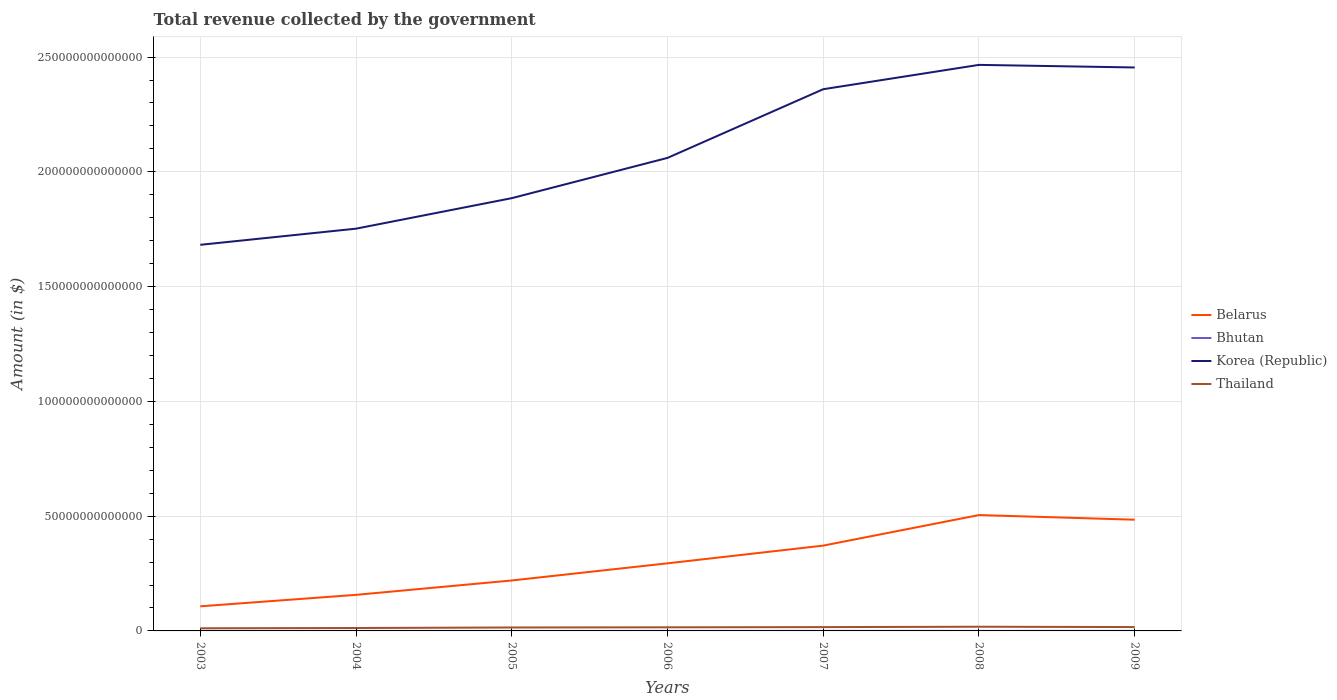Does the line corresponding to Belarus intersect with the line corresponding to Thailand?
Offer a very short reply. No. Is the number of lines equal to the number of legend labels?
Offer a terse response. Yes. Across all years, what is the maximum total revenue collected by the government in Belarus?
Ensure brevity in your answer.  1.07e+13. In which year was the total revenue collected by the government in Belarus maximum?
Make the answer very short. 2003. What is the total total revenue collected by the government in Korea (Republic) in the graph?
Keep it short and to the point. -4.05e+13. What is the difference between the highest and the second highest total revenue collected by the government in Korea (Republic)?
Ensure brevity in your answer.  7.84e+13. What is the difference between the highest and the lowest total revenue collected by the government in Belarus?
Offer a very short reply. 3. How many lines are there?
Provide a succinct answer. 4. What is the difference between two consecutive major ticks on the Y-axis?
Keep it short and to the point. 5.00e+13. Are the values on the major ticks of Y-axis written in scientific E-notation?
Your answer should be compact. No. Does the graph contain grids?
Provide a short and direct response. Yes. How many legend labels are there?
Keep it short and to the point. 4. What is the title of the graph?
Your answer should be compact. Total revenue collected by the government. Does "Norway" appear as one of the legend labels in the graph?
Make the answer very short. No. What is the label or title of the Y-axis?
Your response must be concise. Amount (in $). What is the Amount (in $) of Belarus in 2003?
Your answer should be very brief. 1.07e+13. What is the Amount (in $) in Bhutan in 2003?
Give a very brief answer. 4.75e+09. What is the Amount (in $) of Korea (Republic) in 2003?
Give a very brief answer. 1.68e+14. What is the Amount (in $) in Thailand in 2003?
Ensure brevity in your answer.  1.16e+12. What is the Amount (in $) in Belarus in 2004?
Ensure brevity in your answer.  1.57e+13. What is the Amount (in $) of Bhutan in 2004?
Ensure brevity in your answer.  5.00e+09. What is the Amount (in $) in Korea (Republic) in 2004?
Your response must be concise. 1.75e+14. What is the Amount (in $) of Thailand in 2004?
Make the answer very short. 1.27e+12. What is the Amount (in $) in Belarus in 2005?
Offer a very short reply. 2.20e+13. What is the Amount (in $) of Bhutan in 2005?
Make the answer very short. 6.07e+09. What is the Amount (in $) in Korea (Republic) in 2005?
Ensure brevity in your answer.  1.89e+14. What is the Amount (in $) in Thailand in 2005?
Keep it short and to the point. 1.50e+12. What is the Amount (in $) in Belarus in 2006?
Give a very brief answer. 2.94e+13. What is the Amount (in $) in Bhutan in 2006?
Offer a terse response. 6.90e+09. What is the Amount (in $) of Korea (Republic) in 2006?
Keep it short and to the point. 2.06e+14. What is the Amount (in $) of Thailand in 2006?
Provide a short and direct response. 1.57e+12. What is the Amount (in $) in Belarus in 2007?
Your answer should be very brief. 3.72e+13. What is the Amount (in $) of Bhutan in 2007?
Your response must be concise. 1.01e+1. What is the Amount (in $) in Korea (Republic) in 2007?
Offer a terse response. 2.36e+14. What is the Amount (in $) in Thailand in 2007?
Make the answer very short. 1.66e+12. What is the Amount (in $) of Belarus in 2008?
Give a very brief answer. 5.05e+13. What is the Amount (in $) of Bhutan in 2008?
Your answer should be very brief. 1.23e+1. What is the Amount (in $) of Korea (Republic) in 2008?
Offer a very short reply. 2.47e+14. What is the Amount (in $) in Thailand in 2008?
Your response must be concise. 1.83e+12. What is the Amount (in $) in Belarus in 2009?
Ensure brevity in your answer.  4.85e+13. What is the Amount (in $) of Bhutan in 2009?
Offer a very short reply. 1.40e+1. What is the Amount (in $) in Korea (Republic) in 2009?
Ensure brevity in your answer.  2.45e+14. What is the Amount (in $) in Thailand in 2009?
Make the answer very short. 1.68e+12. Across all years, what is the maximum Amount (in $) of Belarus?
Your answer should be very brief. 5.05e+13. Across all years, what is the maximum Amount (in $) of Bhutan?
Offer a terse response. 1.40e+1. Across all years, what is the maximum Amount (in $) of Korea (Republic)?
Offer a very short reply. 2.47e+14. Across all years, what is the maximum Amount (in $) in Thailand?
Make the answer very short. 1.83e+12. Across all years, what is the minimum Amount (in $) of Belarus?
Your answer should be very brief. 1.07e+13. Across all years, what is the minimum Amount (in $) of Bhutan?
Give a very brief answer. 4.75e+09. Across all years, what is the minimum Amount (in $) of Korea (Republic)?
Your response must be concise. 1.68e+14. Across all years, what is the minimum Amount (in $) in Thailand?
Ensure brevity in your answer.  1.16e+12. What is the total Amount (in $) of Belarus in the graph?
Provide a short and direct response. 2.14e+14. What is the total Amount (in $) in Bhutan in the graph?
Provide a short and direct response. 5.92e+1. What is the total Amount (in $) in Korea (Republic) in the graph?
Your answer should be compact. 1.47e+15. What is the total Amount (in $) of Thailand in the graph?
Your answer should be very brief. 1.07e+13. What is the difference between the Amount (in $) of Belarus in 2003 and that in 2004?
Offer a very short reply. -4.99e+12. What is the difference between the Amount (in $) of Bhutan in 2003 and that in 2004?
Your answer should be very brief. -2.58e+08. What is the difference between the Amount (in $) of Korea (Republic) in 2003 and that in 2004?
Your answer should be compact. -7.03e+12. What is the difference between the Amount (in $) in Thailand in 2003 and that in 2004?
Offer a terse response. -1.16e+11. What is the difference between the Amount (in $) of Belarus in 2003 and that in 2005?
Keep it short and to the point. -1.13e+13. What is the difference between the Amount (in $) in Bhutan in 2003 and that in 2005?
Make the answer very short. -1.32e+09. What is the difference between the Amount (in $) in Korea (Republic) in 2003 and that in 2005?
Ensure brevity in your answer.  -2.03e+13. What is the difference between the Amount (in $) in Thailand in 2003 and that in 2005?
Make the answer very short. -3.40e+11. What is the difference between the Amount (in $) of Belarus in 2003 and that in 2006?
Offer a terse response. -1.87e+13. What is the difference between the Amount (in $) of Bhutan in 2003 and that in 2006?
Make the answer very short. -2.16e+09. What is the difference between the Amount (in $) in Korea (Republic) in 2003 and that in 2006?
Your answer should be compact. -3.79e+13. What is the difference between the Amount (in $) of Thailand in 2003 and that in 2006?
Provide a succinct answer. -4.18e+11. What is the difference between the Amount (in $) in Belarus in 2003 and that in 2007?
Ensure brevity in your answer.  -2.64e+13. What is the difference between the Amount (in $) of Bhutan in 2003 and that in 2007?
Make the answer very short. -5.34e+09. What is the difference between the Amount (in $) in Korea (Republic) in 2003 and that in 2007?
Offer a very short reply. -6.78e+13. What is the difference between the Amount (in $) in Thailand in 2003 and that in 2007?
Give a very brief answer. -5.01e+11. What is the difference between the Amount (in $) of Belarus in 2003 and that in 2008?
Keep it short and to the point. -3.98e+13. What is the difference between the Amount (in $) in Bhutan in 2003 and that in 2008?
Your answer should be compact. -7.60e+09. What is the difference between the Amount (in $) in Korea (Republic) in 2003 and that in 2008?
Your answer should be compact. -7.84e+13. What is the difference between the Amount (in $) of Thailand in 2003 and that in 2008?
Your answer should be very brief. -6.70e+11. What is the difference between the Amount (in $) in Belarus in 2003 and that in 2009?
Offer a very short reply. -3.77e+13. What is the difference between the Amount (in $) in Bhutan in 2003 and that in 2009?
Offer a very short reply. -9.30e+09. What is the difference between the Amount (in $) in Korea (Republic) in 2003 and that in 2009?
Keep it short and to the point. -7.73e+13. What is the difference between the Amount (in $) in Thailand in 2003 and that in 2009?
Ensure brevity in your answer.  -5.28e+11. What is the difference between the Amount (in $) of Belarus in 2004 and that in 2005?
Offer a terse response. -6.26e+12. What is the difference between the Amount (in $) of Bhutan in 2004 and that in 2005?
Provide a succinct answer. -1.06e+09. What is the difference between the Amount (in $) in Korea (Republic) in 2004 and that in 2005?
Your answer should be compact. -1.33e+13. What is the difference between the Amount (in $) in Thailand in 2004 and that in 2005?
Offer a very short reply. -2.24e+11. What is the difference between the Amount (in $) of Belarus in 2004 and that in 2006?
Your answer should be compact. -1.37e+13. What is the difference between the Amount (in $) of Bhutan in 2004 and that in 2006?
Make the answer very short. -1.90e+09. What is the difference between the Amount (in $) of Korea (Republic) in 2004 and that in 2006?
Give a very brief answer. -3.08e+13. What is the difference between the Amount (in $) in Thailand in 2004 and that in 2006?
Your answer should be very brief. -3.02e+11. What is the difference between the Amount (in $) of Belarus in 2004 and that in 2007?
Give a very brief answer. -2.15e+13. What is the difference between the Amount (in $) in Bhutan in 2004 and that in 2007?
Provide a succinct answer. -5.08e+09. What is the difference between the Amount (in $) of Korea (Republic) in 2004 and that in 2007?
Offer a terse response. -6.08e+13. What is the difference between the Amount (in $) of Thailand in 2004 and that in 2007?
Offer a very short reply. -3.85e+11. What is the difference between the Amount (in $) of Belarus in 2004 and that in 2008?
Your answer should be compact. -3.48e+13. What is the difference between the Amount (in $) of Bhutan in 2004 and that in 2008?
Provide a short and direct response. -7.34e+09. What is the difference between the Amount (in $) in Korea (Republic) in 2004 and that in 2008?
Keep it short and to the point. -7.14e+13. What is the difference between the Amount (in $) of Thailand in 2004 and that in 2008?
Your answer should be compact. -5.54e+11. What is the difference between the Amount (in $) in Belarus in 2004 and that in 2009?
Offer a terse response. -3.27e+13. What is the difference between the Amount (in $) of Bhutan in 2004 and that in 2009?
Ensure brevity in your answer.  -9.04e+09. What is the difference between the Amount (in $) in Korea (Republic) in 2004 and that in 2009?
Your answer should be compact. -7.02e+13. What is the difference between the Amount (in $) of Thailand in 2004 and that in 2009?
Give a very brief answer. -4.12e+11. What is the difference between the Amount (in $) in Belarus in 2005 and that in 2006?
Your response must be concise. -7.47e+12. What is the difference between the Amount (in $) in Bhutan in 2005 and that in 2006?
Your answer should be very brief. -8.37e+08. What is the difference between the Amount (in $) in Korea (Republic) in 2005 and that in 2006?
Offer a very short reply. -1.75e+13. What is the difference between the Amount (in $) of Thailand in 2005 and that in 2006?
Your answer should be very brief. -7.79e+1. What is the difference between the Amount (in $) in Belarus in 2005 and that in 2007?
Your answer should be compact. -1.52e+13. What is the difference between the Amount (in $) in Bhutan in 2005 and that in 2007?
Offer a very short reply. -4.02e+09. What is the difference between the Amount (in $) of Korea (Republic) in 2005 and that in 2007?
Your response must be concise. -4.75e+13. What is the difference between the Amount (in $) in Thailand in 2005 and that in 2007?
Give a very brief answer. -1.61e+11. What is the difference between the Amount (in $) in Belarus in 2005 and that in 2008?
Your answer should be compact. -2.85e+13. What is the difference between the Amount (in $) of Bhutan in 2005 and that in 2008?
Provide a succinct answer. -6.28e+09. What is the difference between the Amount (in $) in Korea (Republic) in 2005 and that in 2008?
Your answer should be compact. -5.81e+13. What is the difference between the Amount (in $) of Thailand in 2005 and that in 2008?
Provide a short and direct response. -3.30e+11. What is the difference between the Amount (in $) in Belarus in 2005 and that in 2009?
Your response must be concise. -2.65e+13. What is the difference between the Amount (in $) of Bhutan in 2005 and that in 2009?
Give a very brief answer. -7.98e+09. What is the difference between the Amount (in $) of Korea (Republic) in 2005 and that in 2009?
Your answer should be compact. -5.69e+13. What is the difference between the Amount (in $) of Thailand in 2005 and that in 2009?
Your answer should be compact. -1.88e+11. What is the difference between the Amount (in $) of Belarus in 2006 and that in 2007?
Keep it short and to the point. -7.72e+12. What is the difference between the Amount (in $) of Bhutan in 2006 and that in 2007?
Offer a terse response. -3.18e+09. What is the difference between the Amount (in $) of Korea (Republic) in 2006 and that in 2007?
Keep it short and to the point. -2.99e+13. What is the difference between the Amount (in $) in Thailand in 2006 and that in 2007?
Give a very brief answer. -8.30e+1. What is the difference between the Amount (in $) of Belarus in 2006 and that in 2008?
Your response must be concise. -2.10e+13. What is the difference between the Amount (in $) of Bhutan in 2006 and that in 2008?
Offer a terse response. -5.44e+09. What is the difference between the Amount (in $) in Korea (Republic) in 2006 and that in 2008?
Your answer should be very brief. -4.05e+13. What is the difference between the Amount (in $) in Thailand in 2006 and that in 2008?
Keep it short and to the point. -2.52e+11. What is the difference between the Amount (in $) in Belarus in 2006 and that in 2009?
Your answer should be very brief. -1.90e+13. What is the difference between the Amount (in $) of Bhutan in 2006 and that in 2009?
Your response must be concise. -7.15e+09. What is the difference between the Amount (in $) in Korea (Republic) in 2006 and that in 2009?
Ensure brevity in your answer.  -3.94e+13. What is the difference between the Amount (in $) of Thailand in 2006 and that in 2009?
Your answer should be very brief. -1.10e+11. What is the difference between the Amount (in $) of Belarus in 2007 and that in 2008?
Make the answer very short. -1.33e+13. What is the difference between the Amount (in $) of Bhutan in 2007 and that in 2008?
Your answer should be very brief. -2.26e+09. What is the difference between the Amount (in $) of Korea (Republic) in 2007 and that in 2008?
Provide a short and direct response. -1.06e+13. What is the difference between the Amount (in $) in Thailand in 2007 and that in 2008?
Give a very brief answer. -1.69e+11. What is the difference between the Amount (in $) in Belarus in 2007 and that in 2009?
Keep it short and to the point. -1.13e+13. What is the difference between the Amount (in $) of Bhutan in 2007 and that in 2009?
Give a very brief answer. -3.97e+09. What is the difference between the Amount (in $) of Korea (Republic) in 2007 and that in 2009?
Provide a succinct answer. -9.47e+12. What is the difference between the Amount (in $) in Thailand in 2007 and that in 2009?
Your answer should be very brief. -2.67e+1. What is the difference between the Amount (in $) of Belarus in 2008 and that in 2009?
Offer a terse response. 2.03e+12. What is the difference between the Amount (in $) of Bhutan in 2008 and that in 2009?
Give a very brief answer. -1.70e+09. What is the difference between the Amount (in $) in Korea (Republic) in 2008 and that in 2009?
Provide a succinct answer. 1.13e+12. What is the difference between the Amount (in $) of Thailand in 2008 and that in 2009?
Offer a terse response. 1.42e+11. What is the difference between the Amount (in $) of Belarus in 2003 and the Amount (in $) of Bhutan in 2004?
Your answer should be very brief. 1.07e+13. What is the difference between the Amount (in $) in Belarus in 2003 and the Amount (in $) in Korea (Republic) in 2004?
Ensure brevity in your answer.  -1.65e+14. What is the difference between the Amount (in $) in Belarus in 2003 and the Amount (in $) in Thailand in 2004?
Your answer should be compact. 9.45e+12. What is the difference between the Amount (in $) in Bhutan in 2003 and the Amount (in $) in Korea (Republic) in 2004?
Provide a short and direct response. -1.75e+14. What is the difference between the Amount (in $) in Bhutan in 2003 and the Amount (in $) in Thailand in 2004?
Give a very brief answer. -1.27e+12. What is the difference between the Amount (in $) of Korea (Republic) in 2003 and the Amount (in $) of Thailand in 2004?
Offer a very short reply. 1.67e+14. What is the difference between the Amount (in $) in Belarus in 2003 and the Amount (in $) in Bhutan in 2005?
Provide a succinct answer. 1.07e+13. What is the difference between the Amount (in $) in Belarus in 2003 and the Amount (in $) in Korea (Republic) in 2005?
Your answer should be very brief. -1.78e+14. What is the difference between the Amount (in $) in Belarus in 2003 and the Amount (in $) in Thailand in 2005?
Keep it short and to the point. 9.23e+12. What is the difference between the Amount (in $) in Bhutan in 2003 and the Amount (in $) in Korea (Republic) in 2005?
Your answer should be very brief. -1.89e+14. What is the difference between the Amount (in $) in Bhutan in 2003 and the Amount (in $) in Thailand in 2005?
Provide a short and direct response. -1.49e+12. What is the difference between the Amount (in $) of Korea (Republic) in 2003 and the Amount (in $) of Thailand in 2005?
Provide a succinct answer. 1.67e+14. What is the difference between the Amount (in $) of Belarus in 2003 and the Amount (in $) of Bhutan in 2006?
Your answer should be compact. 1.07e+13. What is the difference between the Amount (in $) in Belarus in 2003 and the Amount (in $) in Korea (Republic) in 2006?
Keep it short and to the point. -1.95e+14. What is the difference between the Amount (in $) of Belarus in 2003 and the Amount (in $) of Thailand in 2006?
Offer a terse response. 9.15e+12. What is the difference between the Amount (in $) in Bhutan in 2003 and the Amount (in $) in Korea (Republic) in 2006?
Offer a terse response. -2.06e+14. What is the difference between the Amount (in $) of Bhutan in 2003 and the Amount (in $) of Thailand in 2006?
Give a very brief answer. -1.57e+12. What is the difference between the Amount (in $) of Korea (Republic) in 2003 and the Amount (in $) of Thailand in 2006?
Give a very brief answer. 1.67e+14. What is the difference between the Amount (in $) in Belarus in 2003 and the Amount (in $) in Bhutan in 2007?
Give a very brief answer. 1.07e+13. What is the difference between the Amount (in $) in Belarus in 2003 and the Amount (in $) in Korea (Republic) in 2007?
Provide a short and direct response. -2.25e+14. What is the difference between the Amount (in $) in Belarus in 2003 and the Amount (in $) in Thailand in 2007?
Offer a very short reply. 9.06e+12. What is the difference between the Amount (in $) in Bhutan in 2003 and the Amount (in $) in Korea (Republic) in 2007?
Your answer should be compact. -2.36e+14. What is the difference between the Amount (in $) in Bhutan in 2003 and the Amount (in $) in Thailand in 2007?
Offer a terse response. -1.65e+12. What is the difference between the Amount (in $) of Korea (Republic) in 2003 and the Amount (in $) of Thailand in 2007?
Ensure brevity in your answer.  1.67e+14. What is the difference between the Amount (in $) in Belarus in 2003 and the Amount (in $) in Bhutan in 2008?
Your response must be concise. 1.07e+13. What is the difference between the Amount (in $) in Belarus in 2003 and the Amount (in $) in Korea (Republic) in 2008?
Ensure brevity in your answer.  -2.36e+14. What is the difference between the Amount (in $) in Belarus in 2003 and the Amount (in $) in Thailand in 2008?
Give a very brief answer. 8.90e+12. What is the difference between the Amount (in $) of Bhutan in 2003 and the Amount (in $) of Korea (Republic) in 2008?
Your answer should be compact. -2.47e+14. What is the difference between the Amount (in $) in Bhutan in 2003 and the Amount (in $) in Thailand in 2008?
Ensure brevity in your answer.  -1.82e+12. What is the difference between the Amount (in $) of Korea (Republic) in 2003 and the Amount (in $) of Thailand in 2008?
Your answer should be compact. 1.66e+14. What is the difference between the Amount (in $) of Belarus in 2003 and the Amount (in $) of Bhutan in 2009?
Your response must be concise. 1.07e+13. What is the difference between the Amount (in $) of Belarus in 2003 and the Amount (in $) of Korea (Republic) in 2009?
Provide a succinct answer. -2.35e+14. What is the difference between the Amount (in $) of Belarus in 2003 and the Amount (in $) of Thailand in 2009?
Make the answer very short. 9.04e+12. What is the difference between the Amount (in $) in Bhutan in 2003 and the Amount (in $) in Korea (Republic) in 2009?
Make the answer very short. -2.45e+14. What is the difference between the Amount (in $) of Bhutan in 2003 and the Amount (in $) of Thailand in 2009?
Your answer should be compact. -1.68e+12. What is the difference between the Amount (in $) of Korea (Republic) in 2003 and the Amount (in $) of Thailand in 2009?
Offer a very short reply. 1.67e+14. What is the difference between the Amount (in $) of Belarus in 2004 and the Amount (in $) of Bhutan in 2005?
Keep it short and to the point. 1.57e+13. What is the difference between the Amount (in $) of Belarus in 2004 and the Amount (in $) of Korea (Republic) in 2005?
Make the answer very short. -1.73e+14. What is the difference between the Amount (in $) in Belarus in 2004 and the Amount (in $) in Thailand in 2005?
Your response must be concise. 1.42e+13. What is the difference between the Amount (in $) in Bhutan in 2004 and the Amount (in $) in Korea (Republic) in 2005?
Make the answer very short. -1.89e+14. What is the difference between the Amount (in $) in Bhutan in 2004 and the Amount (in $) in Thailand in 2005?
Provide a succinct answer. -1.49e+12. What is the difference between the Amount (in $) in Korea (Republic) in 2004 and the Amount (in $) in Thailand in 2005?
Make the answer very short. 1.74e+14. What is the difference between the Amount (in $) of Belarus in 2004 and the Amount (in $) of Bhutan in 2006?
Ensure brevity in your answer.  1.57e+13. What is the difference between the Amount (in $) in Belarus in 2004 and the Amount (in $) in Korea (Republic) in 2006?
Keep it short and to the point. -1.90e+14. What is the difference between the Amount (in $) of Belarus in 2004 and the Amount (in $) of Thailand in 2006?
Give a very brief answer. 1.41e+13. What is the difference between the Amount (in $) of Bhutan in 2004 and the Amount (in $) of Korea (Republic) in 2006?
Your answer should be very brief. -2.06e+14. What is the difference between the Amount (in $) in Bhutan in 2004 and the Amount (in $) in Thailand in 2006?
Your answer should be compact. -1.57e+12. What is the difference between the Amount (in $) of Korea (Republic) in 2004 and the Amount (in $) of Thailand in 2006?
Offer a terse response. 1.74e+14. What is the difference between the Amount (in $) of Belarus in 2004 and the Amount (in $) of Bhutan in 2007?
Offer a very short reply. 1.57e+13. What is the difference between the Amount (in $) in Belarus in 2004 and the Amount (in $) in Korea (Republic) in 2007?
Keep it short and to the point. -2.20e+14. What is the difference between the Amount (in $) of Belarus in 2004 and the Amount (in $) of Thailand in 2007?
Give a very brief answer. 1.41e+13. What is the difference between the Amount (in $) in Bhutan in 2004 and the Amount (in $) in Korea (Republic) in 2007?
Ensure brevity in your answer.  -2.36e+14. What is the difference between the Amount (in $) in Bhutan in 2004 and the Amount (in $) in Thailand in 2007?
Provide a short and direct response. -1.65e+12. What is the difference between the Amount (in $) in Korea (Republic) in 2004 and the Amount (in $) in Thailand in 2007?
Provide a succinct answer. 1.74e+14. What is the difference between the Amount (in $) in Belarus in 2004 and the Amount (in $) in Bhutan in 2008?
Your answer should be very brief. 1.57e+13. What is the difference between the Amount (in $) of Belarus in 2004 and the Amount (in $) of Korea (Republic) in 2008?
Keep it short and to the point. -2.31e+14. What is the difference between the Amount (in $) of Belarus in 2004 and the Amount (in $) of Thailand in 2008?
Your response must be concise. 1.39e+13. What is the difference between the Amount (in $) of Bhutan in 2004 and the Amount (in $) of Korea (Republic) in 2008?
Keep it short and to the point. -2.47e+14. What is the difference between the Amount (in $) of Bhutan in 2004 and the Amount (in $) of Thailand in 2008?
Make the answer very short. -1.82e+12. What is the difference between the Amount (in $) of Korea (Republic) in 2004 and the Amount (in $) of Thailand in 2008?
Ensure brevity in your answer.  1.73e+14. What is the difference between the Amount (in $) in Belarus in 2004 and the Amount (in $) in Bhutan in 2009?
Make the answer very short. 1.57e+13. What is the difference between the Amount (in $) in Belarus in 2004 and the Amount (in $) in Korea (Republic) in 2009?
Give a very brief answer. -2.30e+14. What is the difference between the Amount (in $) in Belarus in 2004 and the Amount (in $) in Thailand in 2009?
Provide a short and direct response. 1.40e+13. What is the difference between the Amount (in $) of Bhutan in 2004 and the Amount (in $) of Korea (Republic) in 2009?
Keep it short and to the point. -2.45e+14. What is the difference between the Amount (in $) of Bhutan in 2004 and the Amount (in $) of Thailand in 2009?
Your answer should be compact. -1.68e+12. What is the difference between the Amount (in $) of Korea (Republic) in 2004 and the Amount (in $) of Thailand in 2009?
Your answer should be very brief. 1.74e+14. What is the difference between the Amount (in $) of Belarus in 2005 and the Amount (in $) of Bhutan in 2006?
Your answer should be compact. 2.20e+13. What is the difference between the Amount (in $) in Belarus in 2005 and the Amount (in $) in Korea (Republic) in 2006?
Provide a succinct answer. -1.84e+14. What is the difference between the Amount (in $) of Belarus in 2005 and the Amount (in $) of Thailand in 2006?
Offer a terse response. 2.04e+13. What is the difference between the Amount (in $) in Bhutan in 2005 and the Amount (in $) in Korea (Republic) in 2006?
Provide a short and direct response. -2.06e+14. What is the difference between the Amount (in $) of Bhutan in 2005 and the Amount (in $) of Thailand in 2006?
Offer a terse response. -1.57e+12. What is the difference between the Amount (in $) of Korea (Republic) in 2005 and the Amount (in $) of Thailand in 2006?
Ensure brevity in your answer.  1.87e+14. What is the difference between the Amount (in $) of Belarus in 2005 and the Amount (in $) of Bhutan in 2007?
Your answer should be very brief. 2.20e+13. What is the difference between the Amount (in $) of Belarus in 2005 and the Amount (in $) of Korea (Republic) in 2007?
Your response must be concise. -2.14e+14. What is the difference between the Amount (in $) in Belarus in 2005 and the Amount (in $) in Thailand in 2007?
Your response must be concise. 2.03e+13. What is the difference between the Amount (in $) in Bhutan in 2005 and the Amount (in $) in Korea (Republic) in 2007?
Provide a short and direct response. -2.36e+14. What is the difference between the Amount (in $) of Bhutan in 2005 and the Amount (in $) of Thailand in 2007?
Your response must be concise. -1.65e+12. What is the difference between the Amount (in $) in Korea (Republic) in 2005 and the Amount (in $) in Thailand in 2007?
Provide a succinct answer. 1.87e+14. What is the difference between the Amount (in $) of Belarus in 2005 and the Amount (in $) of Bhutan in 2008?
Your answer should be very brief. 2.20e+13. What is the difference between the Amount (in $) of Belarus in 2005 and the Amount (in $) of Korea (Republic) in 2008?
Give a very brief answer. -2.25e+14. What is the difference between the Amount (in $) in Belarus in 2005 and the Amount (in $) in Thailand in 2008?
Your response must be concise. 2.02e+13. What is the difference between the Amount (in $) in Bhutan in 2005 and the Amount (in $) in Korea (Republic) in 2008?
Offer a terse response. -2.47e+14. What is the difference between the Amount (in $) of Bhutan in 2005 and the Amount (in $) of Thailand in 2008?
Provide a short and direct response. -1.82e+12. What is the difference between the Amount (in $) of Korea (Republic) in 2005 and the Amount (in $) of Thailand in 2008?
Offer a very short reply. 1.87e+14. What is the difference between the Amount (in $) of Belarus in 2005 and the Amount (in $) of Bhutan in 2009?
Provide a succinct answer. 2.20e+13. What is the difference between the Amount (in $) of Belarus in 2005 and the Amount (in $) of Korea (Republic) in 2009?
Make the answer very short. -2.23e+14. What is the difference between the Amount (in $) in Belarus in 2005 and the Amount (in $) in Thailand in 2009?
Offer a terse response. 2.03e+13. What is the difference between the Amount (in $) of Bhutan in 2005 and the Amount (in $) of Korea (Republic) in 2009?
Your response must be concise. -2.45e+14. What is the difference between the Amount (in $) in Bhutan in 2005 and the Amount (in $) in Thailand in 2009?
Make the answer very short. -1.68e+12. What is the difference between the Amount (in $) of Korea (Republic) in 2005 and the Amount (in $) of Thailand in 2009?
Provide a succinct answer. 1.87e+14. What is the difference between the Amount (in $) in Belarus in 2006 and the Amount (in $) in Bhutan in 2007?
Make the answer very short. 2.94e+13. What is the difference between the Amount (in $) of Belarus in 2006 and the Amount (in $) of Korea (Republic) in 2007?
Keep it short and to the point. -2.07e+14. What is the difference between the Amount (in $) in Belarus in 2006 and the Amount (in $) in Thailand in 2007?
Your response must be concise. 2.78e+13. What is the difference between the Amount (in $) in Bhutan in 2006 and the Amount (in $) in Korea (Republic) in 2007?
Offer a very short reply. -2.36e+14. What is the difference between the Amount (in $) in Bhutan in 2006 and the Amount (in $) in Thailand in 2007?
Give a very brief answer. -1.65e+12. What is the difference between the Amount (in $) in Korea (Republic) in 2006 and the Amount (in $) in Thailand in 2007?
Offer a very short reply. 2.04e+14. What is the difference between the Amount (in $) of Belarus in 2006 and the Amount (in $) of Bhutan in 2008?
Give a very brief answer. 2.94e+13. What is the difference between the Amount (in $) of Belarus in 2006 and the Amount (in $) of Korea (Republic) in 2008?
Offer a very short reply. -2.17e+14. What is the difference between the Amount (in $) in Belarus in 2006 and the Amount (in $) in Thailand in 2008?
Your answer should be compact. 2.76e+13. What is the difference between the Amount (in $) of Bhutan in 2006 and the Amount (in $) of Korea (Republic) in 2008?
Your answer should be very brief. -2.47e+14. What is the difference between the Amount (in $) in Bhutan in 2006 and the Amount (in $) in Thailand in 2008?
Give a very brief answer. -1.82e+12. What is the difference between the Amount (in $) in Korea (Republic) in 2006 and the Amount (in $) in Thailand in 2008?
Make the answer very short. 2.04e+14. What is the difference between the Amount (in $) of Belarus in 2006 and the Amount (in $) of Bhutan in 2009?
Your answer should be compact. 2.94e+13. What is the difference between the Amount (in $) in Belarus in 2006 and the Amount (in $) in Korea (Republic) in 2009?
Make the answer very short. -2.16e+14. What is the difference between the Amount (in $) in Belarus in 2006 and the Amount (in $) in Thailand in 2009?
Ensure brevity in your answer.  2.78e+13. What is the difference between the Amount (in $) in Bhutan in 2006 and the Amount (in $) in Korea (Republic) in 2009?
Provide a short and direct response. -2.45e+14. What is the difference between the Amount (in $) of Bhutan in 2006 and the Amount (in $) of Thailand in 2009?
Your response must be concise. -1.68e+12. What is the difference between the Amount (in $) of Korea (Republic) in 2006 and the Amount (in $) of Thailand in 2009?
Provide a short and direct response. 2.04e+14. What is the difference between the Amount (in $) in Belarus in 2007 and the Amount (in $) in Bhutan in 2008?
Provide a succinct answer. 3.72e+13. What is the difference between the Amount (in $) in Belarus in 2007 and the Amount (in $) in Korea (Republic) in 2008?
Your answer should be very brief. -2.09e+14. What is the difference between the Amount (in $) in Belarus in 2007 and the Amount (in $) in Thailand in 2008?
Your answer should be compact. 3.53e+13. What is the difference between the Amount (in $) in Bhutan in 2007 and the Amount (in $) in Korea (Republic) in 2008?
Your response must be concise. -2.47e+14. What is the difference between the Amount (in $) of Bhutan in 2007 and the Amount (in $) of Thailand in 2008?
Offer a terse response. -1.82e+12. What is the difference between the Amount (in $) in Korea (Republic) in 2007 and the Amount (in $) in Thailand in 2008?
Your answer should be very brief. 2.34e+14. What is the difference between the Amount (in $) of Belarus in 2007 and the Amount (in $) of Bhutan in 2009?
Your answer should be very brief. 3.72e+13. What is the difference between the Amount (in $) of Belarus in 2007 and the Amount (in $) of Korea (Republic) in 2009?
Provide a short and direct response. -2.08e+14. What is the difference between the Amount (in $) of Belarus in 2007 and the Amount (in $) of Thailand in 2009?
Make the answer very short. 3.55e+13. What is the difference between the Amount (in $) in Bhutan in 2007 and the Amount (in $) in Korea (Republic) in 2009?
Give a very brief answer. -2.45e+14. What is the difference between the Amount (in $) in Bhutan in 2007 and the Amount (in $) in Thailand in 2009?
Your response must be concise. -1.67e+12. What is the difference between the Amount (in $) in Korea (Republic) in 2007 and the Amount (in $) in Thailand in 2009?
Make the answer very short. 2.34e+14. What is the difference between the Amount (in $) in Belarus in 2008 and the Amount (in $) in Bhutan in 2009?
Give a very brief answer. 5.05e+13. What is the difference between the Amount (in $) in Belarus in 2008 and the Amount (in $) in Korea (Republic) in 2009?
Your answer should be compact. -1.95e+14. What is the difference between the Amount (in $) of Belarus in 2008 and the Amount (in $) of Thailand in 2009?
Provide a short and direct response. 4.88e+13. What is the difference between the Amount (in $) of Bhutan in 2008 and the Amount (in $) of Korea (Republic) in 2009?
Your response must be concise. -2.45e+14. What is the difference between the Amount (in $) of Bhutan in 2008 and the Amount (in $) of Thailand in 2009?
Give a very brief answer. -1.67e+12. What is the difference between the Amount (in $) of Korea (Republic) in 2008 and the Amount (in $) of Thailand in 2009?
Keep it short and to the point. 2.45e+14. What is the average Amount (in $) of Belarus per year?
Ensure brevity in your answer.  3.06e+13. What is the average Amount (in $) in Bhutan per year?
Your answer should be compact. 8.46e+09. What is the average Amount (in $) in Korea (Republic) per year?
Provide a succinct answer. 2.09e+14. What is the average Amount (in $) of Thailand per year?
Provide a succinct answer. 1.52e+12. In the year 2003, what is the difference between the Amount (in $) in Belarus and Amount (in $) in Bhutan?
Keep it short and to the point. 1.07e+13. In the year 2003, what is the difference between the Amount (in $) of Belarus and Amount (in $) of Korea (Republic)?
Your answer should be compact. -1.57e+14. In the year 2003, what is the difference between the Amount (in $) of Belarus and Amount (in $) of Thailand?
Provide a succinct answer. 9.57e+12. In the year 2003, what is the difference between the Amount (in $) in Bhutan and Amount (in $) in Korea (Republic)?
Your answer should be very brief. -1.68e+14. In the year 2003, what is the difference between the Amount (in $) in Bhutan and Amount (in $) in Thailand?
Your response must be concise. -1.15e+12. In the year 2003, what is the difference between the Amount (in $) in Korea (Republic) and Amount (in $) in Thailand?
Provide a succinct answer. 1.67e+14. In the year 2004, what is the difference between the Amount (in $) in Belarus and Amount (in $) in Bhutan?
Provide a short and direct response. 1.57e+13. In the year 2004, what is the difference between the Amount (in $) in Belarus and Amount (in $) in Korea (Republic)?
Offer a terse response. -1.60e+14. In the year 2004, what is the difference between the Amount (in $) in Belarus and Amount (in $) in Thailand?
Make the answer very short. 1.44e+13. In the year 2004, what is the difference between the Amount (in $) of Bhutan and Amount (in $) of Korea (Republic)?
Make the answer very short. -1.75e+14. In the year 2004, what is the difference between the Amount (in $) in Bhutan and Amount (in $) in Thailand?
Ensure brevity in your answer.  -1.27e+12. In the year 2004, what is the difference between the Amount (in $) of Korea (Republic) and Amount (in $) of Thailand?
Provide a short and direct response. 1.74e+14. In the year 2005, what is the difference between the Amount (in $) in Belarus and Amount (in $) in Bhutan?
Keep it short and to the point. 2.20e+13. In the year 2005, what is the difference between the Amount (in $) of Belarus and Amount (in $) of Korea (Republic)?
Provide a succinct answer. -1.67e+14. In the year 2005, what is the difference between the Amount (in $) in Belarus and Amount (in $) in Thailand?
Ensure brevity in your answer.  2.05e+13. In the year 2005, what is the difference between the Amount (in $) of Bhutan and Amount (in $) of Korea (Republic)?
Your response must be concise. -1.89e+14. In the year 2005, what is the difference between the Amount (in $) of Bhutan and Amount (in $) of Thailand?
Your response must be concise. -1.49e+12. In the year 2005, what is the difference between the Amount (in $) in Korea (Republic) and Amount (in $) in Thailand?
Offer a very short reply. 1.87e+14. In the year 2006, what is the difference between the Amount (in $) of Belarus and Amount (in $) of Bhutan?
Your response must be concise. 2.94e+13. In the year 2006, what is the difference between the Amount (in $) of Belarus and Amount (in $) of Korea (Republic)?
Your answer should be compact. -1.77e+14. In the year 2006, what is the difference between the Amount (in $) in Belarus and Amount (in $) in Thailand?
Your answer should be very brief. 2.79e+13. In the year 2006, what is the difference between the Amount (in $) of Bhutan and Amount (in $) of Korea (Republic)?
Keep it short and to the point. -2.06e+14. In the year 2006, what is the difference between the Amount (in $) of Bhutan and Amount (in $) of Thailand?
Offer a very short reply. -1.57e+12. In the year 2006, what is the difference between the Amount (in $) of Korea (Republic) and Amount (in $) of Thailand?
Offer a terse response. 2.05e+14. In the year 2007, what is the difference between the Amount (in $) of Belarus and Amount (in $) of Bhutan?
Offer a very short reply. 3.72e+13. In the year 2007, what is the difference between the Amount (in $) in Belarus and Amount (in $) in Korea (Republic)?
Your response must be concise. -1.99e+14. In the year 2007, what is the difference between the Amount (in $) in Belarus and Amount (in $) in Thailand?
Keep it short and to the point. 3.55e+13. In the year 2007, what is the difference between the Amount (in $) of Bhutan and Amount (in $) of Korea (Republic)?
Offer a terse response. -2.36e+14. In the year 2007, what is the difference between the Amount (in $) in Bhutan and Amount (in $) in Thailand?
Provide a succinct answer. -1.65e+12. In the year 2007, what is the difference between the Amount (in $) of Korea (Republic) and Amount (in $) of Thailand?
Make the answer very short. 2.34e+14. In the year 2008, what is the difference between the Amount (in $) in Belarus and Amount (in $) in Bhutan?
Give a very brief answer. 5.05e+13. In the year 2008, what is the difference between the Amount (in $) of Belarus and Amount (in $) of Korea (Republic)?
Give a very brief answer. -1.96e+14. In the year 2008, what is the difference between the Amount (in $) in Belarus and Amount (in $) in Thailand?
Provide a short and direct response. 4.87e+13. In the year 2008, what is the difference between the Amount (in $) of Bhutan and Amount (in $) of Korea (Republic)?
Offer a terse response. -2.47e+14. In the year 2008, what is the difference between the Amount (in $) in Bhutan and Amount (in $) in Thailand?
Offer a very short reply. -1.81e+12. In the year 2008, what is the difference between the Amount (in $) of Korea (Republic) and Amount (in $) of Thailand?
Your answer should be very brief. 2.45e+14. In the year 2009, what is the difference between the Amount (in $) of Belarus and Amount (in $) of Bhutan?
Give a very brief answer. 4.84e+13. In the year 2009, what is the difference between the Amount (in $) in Belarus and Amount (in $) in Korea (Republic)?
Your answer should be compact. -1.97e+14. In the year 2009, what is the difference between the Amount (in $) in Belarus and Amount (in $) in Thailand?
Provide a short and direct response. 4.68e+13. In the year 2009, what is the difference between the Amount (in $) of Bhutan and Amount (in $) of Korea (Republic)?
Offer a very short reply. -2.45e+14. In the year 2009, what is the difference between the Amount (in $) of Bhutan and Amount (in $) of Thailand?
Give a very brief answer. -1.67e+12. In the year 2009, what is the difference between the Amount (in $) in Korea (Republic) and Amount (in $) in Thailand?
Offer a very short reply. 2.44e+14. What is the ratio of the Amount (in $) in Belarus in 2003 to that in 2004?
Offer a very short reply. 0.68. What is the ratio of the Amount (in $) in Bhutan in 2003 to that in 2004?
Give a very brief answer. 0.95. What is the ratio of the Amount (in $) of Korea (Republic) in 2003 to that in 2004?
Your answer should be compact. 0.96. What is the ratio of the Amount (in $) of Thailand in 2003 to that in 2004?
Your answer should be compact. 0.91. What is the ratio of the Amount (in $) in Belarus in 2003 to that in 2005?
Give a very brief answer. 0.49. What is the ratio of the Amount (in $) in Bhutan in 2003 to that in 2005?
Provide a succinct answer. 0.78. What is the ratio of the Amount (in $) of Korea (Republic) in 2003 to that in 2005?
Ensure brevity in your answer.  0.89. What is the ratio of the Amount (in $) of Thailand in 2003 to that in 2005?
Ensure brevity in your answer.  0.77. What is the ratio of the Amount (in $) in Belarus in 2003 to that in 2006?
Keep it short and to the point. 0.36. What is the ratio of the Amount (in $) of Bhutan in 2003 to that in 2006?
Your answer should be compact. 0.69. What is the ratio of the Amount (in $) in Korea (Republic) in 2003 to that in 2006?
Keep it short and to the point. 0.82. What is the ratio of the Amount (in $) of Thailand in 2003 to that in 2006?
Provide a succinct answer. 0.73. What is the ratio of the Amount (in $) of Belarus in 2003 to that in 2007?
Your answer should be very brief. 0.29. What is the ratio of the Amount (in $) in Bhutan in 2003 to that in 2007?
Your answer should be very brief. 0.47. What is the ratio of the Amount (in $) of Korea (Republic) in 2003 to that in 2007?
Ensure brevity in your answer.  0.71. What is the ratio of the Amount (in $) of Thailand in 2003 to that in 2007?
Ensure brevity in your answer.  0.7. What is the ratio of the Amount (in $) of Belarus in 2003 to that in 2008?
Make the answer very short. 0.21. What is the ratio of the Amount (in $) in Bhutan in 2003 to that in 2008?
Your response must be concise. 0.38. What is the ratio of the Amount (in $) in Korea (Republic) in 2003 to that in 2008?
Make the answer very short. 0.68. What is the ratio of the Amount (in $) of Thailand in 2003 to that in 2008?
Your answer should be very brief. 0.63. What is the ratio of the Amount (in $) in Belarus in 2003 to that in 2009?
Make the answer very short. 0.22. What is the ratio of the Amount (in $) of Bhutan in 2003 to that in 2009?
Offer a terse response. 0.34. What is the ratio of the Amount (in $) of Korea (Republic) in 2003 to that in 2009?
Give a very brief answer. 0.69. What is the ratio of the Amount (in $) of Thailand in 2003 to that in 2009?
Offer a very short reply. 0.69. What is the ratio of the Amount (in $) of Belarus in 2004 to that in 2005?
Give a very brief answer. 0.71. What is the ratio of the Amount (in $) of Bhutan in 2004 to that in 2005?
Offer a very short reply. 0.82. What is the ratio of the Amount (in $) in Korea (Republic) in 2004 to that in 2005?
Make the answer very short. 0.93. What is the ratio of the Amount (in $) of Thailand in 2004 to that in 2005?
Your answer should be very brief. 0.85. What is the ratio of the Amount (in $) of Belarus in 2004 to that in 2006?
Make the answer very short. 0.53. What is the ratio of the Amount (in $) of Bhutan in 2004 to that in 2006?
Your answer should be very brief. 0.72. What is the ratio of the Amount (in $) in Korea (Republic) in 2004 to that in 2006?
Your response must be concise. 0.85. What is the ratio of the Amount (in $) of Thailand in 2004 to that in 2006?
Keep it short and to the point. 0.81. What is the ratio of the Amount (in $) of Belarus in 2004 to that in 2007?
Offer a very short reply. 0.42. What is the ratio of the Amount (in $) of Bhutan in 2004 to that in 2007?
Offer a very short reply. 0.5. What is the ratio of the Amount (in $) in Korea (Republic) in 2004 to that in 2007?
Make the answer very short. 0.74. What is the ratio of the Amount (in $) of Thailand in 2004 to that in 2007?
Your answer should be very brief. 0.77. What is the ratio of the Amount (in $) in Belarus in 2004 to that in 2008?
Your answer should be very brief. 0.31. What is the ratio of the Amount (in $) of Bhutan in 2004 to that in 2008?
Your answer should be compact. 0.41. What is the ratio of the Amount (in $) of Korea (Republic) in 2004 to that in 2008?
Your answer should be very brief. 0.71. What is the ratio of the Amount (in $) in Thailand in 2004 to that in 2008?
Give a very brief answer. 0.7. What is the ratio of the Amount (in $) in Belarus in 2004 to that in 2009?
Ensure brevity in your answer.  0.32. What is the ratio of the Amount (in $) of Bhutan in 2004 to that in 2009?
Provide a short and direct response. 0.36. What is the ratio of the Amount (in $) in Korea (Republic) in 2004 to that in 2009?
Your answer should be compact. 0.71. What is the ratio of the Amount (in $) in Thailand in 2004 to that in 2009?
Give a very brief answer. 0.76. What is the ratio of the Amount (in $) in Belarus in 2005 to that in 2006?
Offer a very short reply. 0.75. What is the ratio of the Amount (in $) in Bhutan in 2005 to that in 2006?
Give a very brief answer. 0.88. What is the ratio of the Amount (in $) of Korea (Republic) in 2005 to that in 2006?
Your answer should be very brief. 0.91. What is the ratio of the Amount (in $) of Thailand in 2005 to that in 2006?
Make the answer very short. 0.95. What is the ratio of the Amount (in $) in Belarus in 2005 to that in 2007?
Keep it short and to the point. 0.59. What is the ratio of the Amount (in $) in Bhutan in 2005 to that in 2007?
Offer a very short reply. 0.6. What is the ratio of the Amount (in $) in Korea (Republic) in 2005 to that in 2007?
Your answer should be very brief. 0.8. What is the ratio of the Amount (in $) of Thailand in 2005 to that in 2007?
Offer a very short reply. 0.9. What is the ratio of the Amount (in $) of Belarus in 2005 to that in 2008?
Ensure brevity in your answer.  0.44. What is the ratio of the Amount (in $) in Bhutan in 2005 to that in 2008?
Your answer should be compact. 0.49. What is the ratio of the Amount (in $) in Korea (Republic) in 2005 to that in 2008?
Make the answer very short. 0.76. What is the ratio of the Amount (in $) in Thailand in 2005 to that in 2008?
Make the answer very short. 0.82. What is the ratio of the Amount (in $) in Belarus in 2005 to that in 2009?
Your answer should be compact. 0.45. What is the ratio of the Amount (in $) of Bhutan in 2005 to that in 2009?
Provide a short and direct response. 0.43. What is the ratio of the Amount (in $) of Korea (Republic) in 2005 to that in 2009?
Keep it short and to the point. 0.77. What is the ratio of the Amount (in $) of Thailand in 2005 to that in 2009?
Provide a succinct answer. 0.89. What is the ratio of the Amount (in $) of Belarus in 2006 to that in 2007?
Keep it short and to the point. 0.79. What is the ratio of the Amount (in $) of Bhutan in 2006 to that in 2007?
Your answer should be very brief. 0.68. What is the ratio of the Amount (in $) in Korea (Republic) in 2006 to that in 2007?
Offer a very short reply. 0.87. What is the ratio of the Amount (in $) in Thailand in 2006 to that in 2007?
Ensure brevity in your answer.  0.95. What is the ratio of the Amount (in $) in Belarus in 2006 to that in 2008?
Offer a terse response. 0.58. What is the ratio of the Amount (in $) in Bhutan in 2006 to that in 2008?
Your answer should be compact. 0.56. What is the ratio of the Amount (in $) of Korea (Republic) in 2006 to that in 2008?
Give a very brief answer. 0.84. What is the ratio of the Amount (in $) in Thailand in 2006 to that in 2008?
Provide a succinct answer. 0.86. What is the ratio of the Amount (in $) in Belarus in 2006 to that in 2009?
Provide a short and direct response. 0.61. What is the ratio of the Amount (in $) of Bhutan in 2006 to that in 2009?
Give a very brief answer. 0.49. What is the ratio of the Amount (in $) in Korea (Republic) in 2006 to that in 2009?
Your answer should be compact. 0.84. What is the ratio of the Amount (in $) of Thailand in 2006 to that in 2009?
Your answer should be compact. 0.93. What is the ratio of the Amount (in $) of Belarus in 2007 to that in 2008?
Your answer should be very brief. 0.74. What is the ratio of the Amount (in $) in Bhutan in 2007 to that in 2008?
Provide a short and direct response. 0.82. What is the ratio of the Amount (in $) of Korea (Republic) in 2007 to that in 2008?
Your answer should be very brief. 0.96. What is the ratio of the Amount (in $) in Thailand in 2007 to that in 2008?
Offer a terse response. 0.91. What is the ratio of the Amount (in $) in Belarus in 2007 to that in 2009?
Provide a short and direct response. 0.77. What is the ratio of the Amount (in $) in Bhutan in 2007 to that in 2009?
Provide a succinct answer. 0.72. What is the ratio of the Amount (in $) in Korea (Republic) in 2007 to that in 2009?
Make the answer very short. 0.96. What is the ratio of the Amount (in $) of Thailand in 2007 to that in 2009?
Your answer should be compact. 0.98. What is the ratio of the Amount (in $) in Belarus in 2008 to that in 2009?
Provide a succinct answer. 1.04. What is the ratio of the Amount (in $) of Bhutan in 2008 to that in 2009?
Ensure brevity in your answer.  0.88. What is the ratio of the Amount (in $) of Korea (Republic) in 2008 to that in 2009?
Your answer should be very brief. 1. What is the ratio of the Amount (in $) of Thailand in 2008 to that in 2009?
Provide a succinct answer. 1.08. What is the difference between the highest and the second highest Amount (in $) of Belarus?
Offer a very short reply. 2.03e+12. What is the difference between the highest and the second highest Amount (in $) of Bhutan?
Offer a terse response. 1.70e+09. What is the difference between the highest and the second highest Amount (in $) in Korea (Republic)?
Your answer should be very brief. 1.13e+12. What is the difference between the highest and the second highest Amount (in $) in Thailand?
Provide a short and direct response. 1.42e+11. What is the difference between the highest and the lowest Amount (in $) of Belarus?
Your answer should be compact. 3.98e+13. What is the difference between the highest and the lowest Amount (in $) in Bhutan?
Ensure brevity in your answer.  9.30e+09. What is the difference between the highest and the lowest Amount (in $) in Korea (Republic)?
Offer a terse response. 7.84e+13. What is the difference between the highest and the lowest Amount (in $) of Thailand?
Make the answer very short. 6.70e+11. 